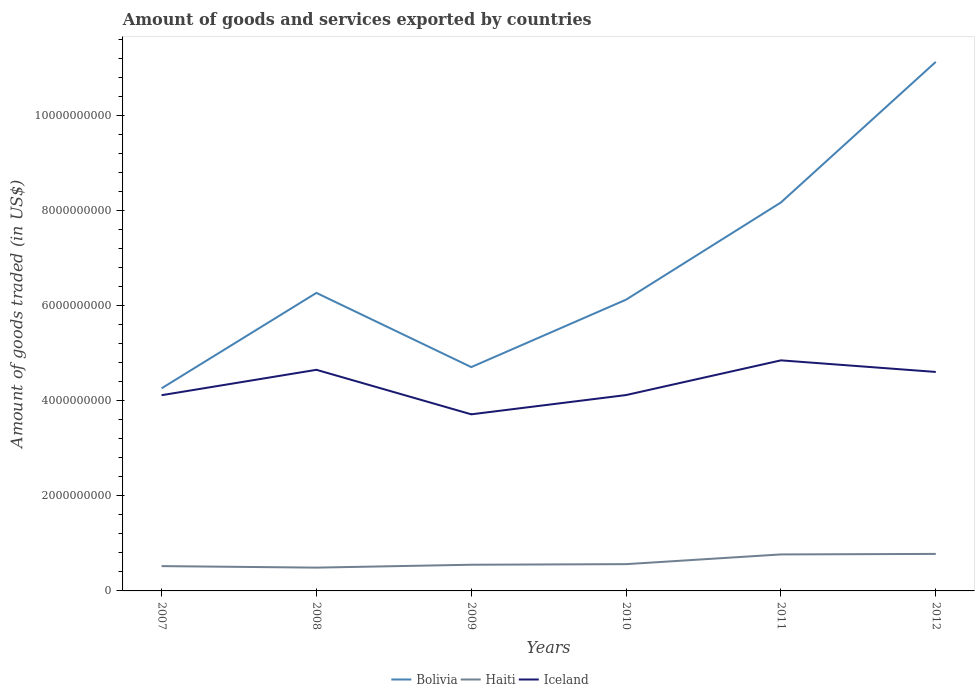Does the line corresponding to Bolivia intersect with the line corresponding to Haiti?
Keep it short and to the point. No. Is the number of lines equal to the number of legend labels?
Your answer should be very brief. Yes. Across all years, what is the maximum total amount of goods and services exported in Iceland?
Give a very brief answer. 3.72e+09. What is the total total amount of goods and services exported in Haiti in the graph?
Your answer should be compact. -2.89e+07. What is the difference between the highest and the second highest total amount of goods and services exported in Haiti?
Keep it short and to the point. 2.89e+08. What is the difference between the highest and the lowest total amount of goods and services exported in Iceland?
Ensure brevity in your answer.  3. Is the total amount of goods and services exported in Bolivia strictly greater than the total amount of goods and services exported in Haiti over the years?
Ensure brevity in your answer.  No. How many years are there in the graph?
Provide a succinct answer. 6. Does the graph contain grids?
Provide a succinct answer. No. Where does the legend appear in the graph?
Offer a very short reply. Bottom center. How are the legend labels stacked?
Your response must be concise. Horizontal. What is the title of the graph?
Provide a short and direct response. Amount of goods and services exported by countries. What is the label or title of the X-axis?
Ensure brevity in your answer.  Years. What is the label or title of the Y-axis?
Your response must be concise. Amount of goods traded (in US$). What is the Amount of goods traded (in US$) of Bolivia in 2007?
Give a very brief answer. 4.26e+09. What is the Amount of goods traded (in US$) in Haiti in 2007?
Offer a very short reply. 5.22e+08. What is the Amount of goods traded (in US$) of Iceland in 2007?
Your answer should be compact. 4.12e+09. What is the Amount of goods traded (in US$) in Bolivia in 2008?
Make the answer very short. 6.27e+09. What is the Amount of goods traded (in US$) of Haiti in 2008?
Offer a terse response. 4.90e+08. What is the Amount of goods traded (in US$) of Iceland in 2008?
Provide a short and direct response. 4.65e+09. What is the Amount of goods traded (in US$) of Bolivia in 2009?
Your response must be concise. 4.71e+09. What is the Amount of goods traded (in US$) of Haiti in 2009?
Offer a terse response. 5.51e+08. What is the Amount of goods traded (in US$) in Iceland in 2009?
Your response must be concise. 3.72e+09. What is the Amount of goods traded (in US$) in Bolivia in 2010?
Give a very brief answer. 6.13e+09. What is the Amount of goods traded (in US$) of Haiti in 2010?
Keep it short and to the point. 5.63e+08. What is the Amount of goods traded (in US$) of Iceland in 2010?
Keep it short and to the point. 4.12e+09. What is the Amount of goods traded (in US$) of Bolivia in 2011?
Provide a succinct answer. 8.17e+09. What is the Amount of goods traded (in US$) of Haiti in 2011?
Your answer should be very brief. 7.68e+08. What is the Amount of goods traded (in US$) of Iceland in 2011?
Give a very brief answer. 4.85e+09. What is the Amount of goods traded (in US$) in Bolivia in 2012?
Your response must be concise. 1.11e+1. What is the Amount of goods traded (in US$) in Haiti in 2012?
Provide a succinct answer. 7.79e+08. What is the Amount of goods traded (in US$) in Iceland in 2012?
Offer a very short reply. 4.61e+09. Across all years, what is the maximum Amount of goods traded (in US$) in Bolivia?
Provide a short and direct response. 1.11e+1. Across all years, what is the maximum Amount of goods traded (in US$) of Haiti?
Keep it short and to the point. 7.79e+08. Across all years, what is the maximum Amount of goods traded (in US$) of Iceland?
Your answer should be very brief. 4.85e+09. Across all years, what is the minimum Amount of goods traded (in US$) in Bolivia?
Make the answer very short. 4.26e+09. Across all years, what is the minimum Amount of goods traded (in US$) of Haiti?
Offer a very short reply. 4.90e+08. Across all years, what is the minimum Amount of goods traded (in US$) in Iceland?
Keep it short and to the point. 3.72e+09. What is the total Amount of goods traded (in US$) of Bolivia in the graph?
Your answer should be very brief. 4.07e+1. What is the total Amount of goods traded (in US$) of Haiti in the graph?
Make the answer very short. 3.67e+09. What is the total Amount of goods traded (in US$) in Iceland in the graph?
Give a very brief answer. 2.61e+1. What is the difference between the Amount of goods traded (in US$) of Bolivia in 2007 and that in 2008?
Keep it short and to the point. -2.01e+09. What is the difference between the Amount of goods traded (in US$) of Haiti in 2007 and that in 2008?
Make the answer very short. 3.19e+07. What is the difference between the Amount of goods traded (in US$) in Iceland in 2007 and that in 2008?
Provide a succinct answer. -5.34e+08. What is the difference between the Amount of goods traded (in US$) of Bolivia in 2007 and that in 2009?
Offer a terse response. -4.47e+08. What is the difference between the Amount of goods traded (in US$) of Haiti in 2007 and that in 2009?
Offer a very short reply. -2.89e+07. What is the difference between the Amount of goods traded (in US$) in Iceland in 2007 and that in 2009?
Give a very brief answer. 4.02e+08. What is the difference between the Amount of goods traded (in US$) in Bolivia in 2007 and that in 2010?
Provide a succinct answer. -1.87e+09. What is the difference between the Amount of goods traded (in US$) of Haiti in 2007 and that in 2010?
Ensure brevity in your answer.  -4.13e+07. What is the difference between the Amount of goods traded (in US$) of Iceland in 2007 and that in 2010?
Make the answer very short. -3.23e+06. What is the difference between the Amount of goods traded (in US$) in Bolivia in 2007 and that in 2011?
Give a very brief answer. -3.91e+09. What is the difference between the Amount of goods traded (in US$) of Haiti in 2007 and that in 2011?
Provide a short and direct response. -2.46e+08. What is the difference between the Amount of goods traded (in US$) in Iceland in 2007 and that in 2011?
Provide a succinct answer. -7.33e+08. What is the difference between the Amount of goods traded (in US$) in Bolivia in 2007 and that in 2012?
Offer a very short reply. -6.87e+09. What is the difference between the Amount of goods traded (in US$) of Haiti in 2007 and that in 2012?
Keep it short and to the point. -2.57e+08. What is the difference between the Amount of goods traded (in US$) of Iceland in 2007 and that in 2012?
Your response must be concise. -4.89e+08. What is the difference between the Amount of goods traded (in US$) in Bolivia in 2008 and that in 2009?
Ensure brevity in your answer.  1.56e+09. What is the difference between the Amount of goods traded (in US$) in Haiti in 2008 and that in 2009?
Give a very brief answer. -6.08e+07. What is the difference between the Amount of goods traded (in US$) in Iceland in 2008 and that in 2009?
Give a very brief answer. 9.37e+08. What is the difference between the Amount of goods traded (in US$) of Bolivia in 2008 and that in 2010?
Offer a terse response. 1.42e+08. What is the difference between the Amount of goods traded (in US$) of Haiti in 2008 and that in 2010?
Your answer should be compact. -7.32e+07. What is the difference between the Amount of goods traded (in US$) of Iceland in 2008 and that in 2010?
Your response must be concise. 5.31e+08. What is the difference between the Amount of goods traded (in US$) of Bolivia in 2008 and that in 2011?
Ensure brevity in your answer.  -1.90e+09. What is the difference between the Amount of goods traded (in US$) of Haiti in 2008 and that in 2011?
Your response must be concise. -2.78e+08. What is the difference between the Amount of goods traded (in US$) of Iceland in 2008 and that in 2011?
Offer a very short reply. -1.99e+08. What is the difference between the Amount of goods traded (in US$) of Bolivia in 2008 and that in 2012?
Your response must be concise. -4.86e+09. What is the difference between the Amount of goods traded (in US$) of Haiti in 2008 and that in 2012?
Provide a succinct answer. -2.89e+08. What is the difference between the Amount of goods traded (in US$) of Iceland in 2008 and that in 2012?
Make the answer very short. 4.49e+07. What is the difference between the Amount of goods traded (in US$) in Bolivia in 2009 and that in 2010?
Keep it short and to the point. -1.42e+09. What is the difference between the Amount of goods traded (in US$) of Haiti in 2009 and that in 2010?
Give a very brief answer. -1.24e+07. What is the difference between the Amount of goods traded (in US$) of Iceland in 2009 and that in 2010?
Your answer should be compact. -4.06e+08. What is the difference between the Amount of goods traded (in US$) of Bolivia in 2009 and that in 2011?
Offer a terse response. -3.47e+09. What is the difference between the Amount of goods traded (in US$) of Haiti in 2009 and that in 2011?
Offer a terse response. -2.17e+08. What is the difference between the Amount of goods traded (in US$) in Iceland in 2009 and that in 2011?
Your response must be concise. -1.14e+09. What is the difference between the Amount of goods traded (in US$) in Bolivia in 2009 and that in 2012?
Provide a succinct answer. -6.42e+09. What is the difference between the Amount of goods traded (in US$) of Haiti in 2009 and that in 2012?
Give a very brief answer. -2.28e+08. What is the difference between the Amount of goods traded (in US$) in Iceland in 2009 and that in 2012?
Your answer should be compact. -8.92e+08. What is the difference between the Amount of goods traded (in US$) in Bolivia in 2010 and that in 2011?
Provide a short and direct response. -2.05e+09. What is the difference between the Amount of goods traded (in US$) of Haiti in 2010 and that in 2011?
Provide a succinct answer. -2.05e+08. What is the difference between the Amount of goods traded (in US$) of Iceland in 2010 and that in 2011?
Your response must be concise. -7.30e+08. What is the difference between the Amount of goods traded (in US$) in Bolivia in 2010 and that in 2012?
Keep it short and to the point. -5.00e+09. What is the difference between the Amount of goods traded (in US$) of Haiti in 2010 and that in 2012?
Your answer should be very brief. -2.15e+08. What is the difference between the Amount of goods traded (in US$) in Iceland in 2010 and that in 2012?
Offer a terse response. -4.86e+08. What is the difference between the Amount of goods traded (in US$) in Bolivia in 2011 and that in 2012?
Your response must be concise. -2.96e+09. What is the difference between the Amount of goods traded (in US$) of Haiti in 2011 and that in 2012?
Your answer should be compact. -1.08e+07. What is the difference between the Amount of goods traded (in US$) of Iceland in 2011 and that in 2012?
Keep it short and to the point. 2.44e+08. What is the difference between the Amount of goods traded (in US$) of Bolivia in 2007 and the Amount of goods traded (in US$) of Haiti in 2008?
Your response must be concise. 3.77e+09. What is the difference between the Amount of goods traded (in US$) of Bolivia in 2007 and the Amount of goods traded (in US$) of Iceland in 2008?
Make the answer very short. -3.90e+08. What is the difference between the Amount of goods traded (in US$) of Haiti in 2007 and the Amount of goods traded (in US$) of Iceland in 2008?
Provide a succinct answer. -4.13e+09. What is the difference between the Amount of goods traded (in US$) in Bolivia in 2007 and the Amount of goods traded (in US$) in Haiti in 2009?
Your response must be concise. 3.71e+09. What is the difference between the Amount of goods traded (in US$) of Bolivia in 2007 and the Amount of goods traded (in US$) of Iceland in 2009?
Offer a terse response. 5.47e+08. What is the difference between the Amount of goods traded (in US$) in Haiti in 2007 and the Amount of goods traded (in US$) in Iceland in 2009?
Ensure brevity in your answer.  -3.19e+09. What is the difference between the Amount of goods traded (in US$) in Bolivia in 2007 and the Amount of goods traded (in US$) in Haiti in 2010?
Offer a very short reply. 3.70e+09. What is the difference between the Amount of goods traded (in US$) in Bolivia in 2007 and the Amount of goods traded (in US$) in Iceland in 2010?
Your answer should be very brief. 1.41e+08. What is the difference between the Amount of goods traded (in US$) in Haiti in 2007 and the Amount of goods traded (in US$) in Iceland in 2010?
Provide a short and direct response. -3.60e+09. What is the difference between the Amount of goods traded (in US$) of Bolivia in 2007 and the Amount of goods traded (in US$) of Haiti in 2011?
Keep it short and to the point. 3.49e+09. What is the difference between the Amount of goods traded (in US$) of Bolivia in 2007 and the Amount of goods traded (in US$) of Iceland in 2011?
Your answer should be compact. -5.89e+08. What is the difference between the Amount of goods traded (in US$) of Haiti in 2007 and the Amount of goods traded (in US$) of Iceland in 2011?
Ensure brevity in your answer.  -4.33e+09. What is the difference between the Amount of goods traded (in US$) of Bolivia in 2007 and the Amount of goods traded (in US$) of Haiti in 2012?
Your answer should be very brief. 3.48e+09. What is the difference between the Amount of goods traded (in US$) of Bolivia in 2007 and the Amount of goods traded (in US$) of Iceland in 2012?
Give a very brief answer. -3.45e+08. What is the difference between the Amount of goods traded (in US$) of Haiti in 2007 and the Amount of goods traded (in US$) of Iceland in 2012?
Make the answer very short. -4.09e+09. What is the difference between the Amount of goods traded (in US$) of Bolivia in 2008 and the Amount of goods traded (in US$) of Haiti in 2009?
Your answer should be very brief. 5.72e+09. What is the difference between the Amount of goods traded (in US$) in Bolivia in 2008 and the Amount of goods traded (in US$) in Iceland in 2009?
Provide a succinct answer. 2.56e+09. What is the difference between the Amount of goods traded (in US$) in Haiti in 2008 and the Amount of goods traded (in US$) in Iceland in 2009?
Offer a very short reply. -3.23e+09. What is the difference between the Amount of goods traded (in US$) in Bolivia in 2008 and the Amount of goods traded (in US$) in Haiti in 2010?
Offer a terse response. 5.71e+09. What is the difference between the Amount of goods traded (in US$) of Bolivia in 2008 and the Amount of goods traded (in US$) of Iceland in 2010?
Provide a short and direct response. 2.15e+09. What is the difference between the Amount of goods traded (in US$) of Haiti in 2008 and the Amount of goods traded (in US$) of Iceland in 2010?
Ensure brevity in your answer.  -3.63e+09. What is the difference between the Amount of goods traded (in US$) of Bolivia in 2008 and the Amount of goods traded (in US$) of Haiti in 2011?
Give a very brief answer. 5.50e+09. What is the difference between the Amount of goods traded (in US$) in Bolivia in 2008 and the Amount of goods traded (in US$) in Iceland in 2011?
Make the answer very short. 1.42e+09. What is the difference between the Amount of goods traded (in US$) of Haiti in 2008 and the Amount of goods traded (in US$) of Iceland in 2011?
Provide a succinct answer. -4.36e+09. What is the difference between the Amount of goods traded (in US$) of Bolivia in 2008 and the Amount of goods traded (in US$) of Haiti in 2012?
Keep it short and to the point. 5.49e+09. What is the difference between the Amount of goods traded (in US$) of Bolivia in 2008 and the Amount of goods traded (in US$) of Iceland in 2012?
Provide a succinct answer. 1.66e+09. What is the difference between the Amount of goods traded (in US$) in Haiti in 2008 and the Amount of goods traded (in US$) in Iceland in 2012?
Give a very brief answer. -4.12e+09. What is the difference between the Amount of goods traded (in US$) in Bolivia in 2009 and the Amount of goods traded (in US$) in Haiti in 2010?
Your answer should be compact. 4.15e+09. What is the difference between the Amount of goods traded (in US$) in Bolivia in 2009 and the Amount of goods traded (in US$) in Iceland in 2010?
Offer a very short reply. 5.88e+08. What is the difference between the Amount of goods traded (in US$) in Haiti in 2009 and the Amount of goods traded (in US$) in Iceland in 2010?
Ensure brevity in your answer.  -3.57e+09. What is the difference between the Amount of goods traded (in US$) in Bolivia in 2009 and the Amount of goods traded (in US$) in Haiti in 2011?
Make the answer very short. 3.94e+09. What is the difference between the Amount of goods traded (in US$) in Bolivia in 2009 and the Amount of goods traded (in US$) in Iceland in 2011?
Keep it short and to the point. -1.42e+08. What is the difference between the Amount of goods traded (in US$) in Haiti in 2009 and the Amount of goods traded (in US$) in Iceland in 2011?
Offer a terse response. -4.30e+09. What is the difference between the Amount of goods traded (in US$) of Bolivia in 2009 and the Amount of goods traded (in US$) of Haiti in 2012?
Offer a terse response. 3.93e+09. What is the difference between the Amount of goods traded (in US$) of Bolivia in 2009 and the Amount of goods traded (in US$) of Iceland in 2012?
Your answer should be very brief. 1.02e+08. What is the difference between the Amount of goods traded (in US$) in Haiti in 2009 and the Amount of goods traded (in US$) in Iceland in 2012?
Your response must be concise. -4.06e+09. What is the difference between the Amount of goods traded (in US$) in Bolivia in 2010 and the Amount of goods traded (in US$) in Haiti in 2011?
Offer a terse response. 5.36e+09. What is the difference between the Amount of goods traded (in US$) of Bolivia in 2010 and the Amount of goods traded (in US$) of Iceland in 2011?
Make the answer very short. 1.28e+09. What is the difference between the Amount of goods traded (in US$) in Haiti in 2010 and the Amount of goods traded (in US$) in Iceland in 2011?
Keep it short and to the point. -4.29e+09. What is the difference between the Amount of goods traded (in US$) in Bolivia in 2010 and the Amount of goods traded (in US$) in Haiti in 2012?
Your answer should be very brief. 5.35e+09. What is the difference between the Amount of goods traded (in US$) of Bolivia in 2010 and the Amount of goods traded (in US$) of Iceland in 2012?
Your answer should be compact. 1.52e+09. What is the difference between the Amount of goods traded (in US$) in Haiti in 2010 and the Amount of goods traded (in US$) in Iceland in 2012?
Your response must be concise. -4.04e+09. What is the difference between the Amount of goods traded (in US$) of Bolivia in 2011 and the Amount of goods traded (in US$) of Haiti in 2012?
Ensure brevity in your answer.  7.40e+09. What is the difference between the Amount of goods traded (in US$) in Bolivia in 2011 and the Amount of goods traded (in US$) in Iceland in 2012?
Your answer should be very brief. 3.57e+09. What is the difference between the Amount of goods traded (in US$) in Haiti in 2011 and the Amount of goods traded (in US$) in Iceland in 2012?
Your answer should be very brief. -3.84e+09. What is the average Amount of goods traded (in US$) of Bolivia per year?
Make the answer very short. 6.78e+09. What is the average Amount of goods traded (in US$) in Haiti per year?
Make the answer very short. 6.12e+08. What is the average Amount of goods traded (in US$) of Iceland per year?
Offer a very short reply. 4.34e+09. In the year 2007, what is the difference between the Amount of goods traded (in US$) of Bolivia and Amount of goods traded (in US$) of Haiti?
Provide a short and direct response. 3.74e+09. In the year 2007, what is the difference between the Amount of goods traded (in US$) of Bolivia and Amount of goods traded (in US$) of Iceland?
Offer a terse response. 1.44e+08. In the year 2007, what is the difference between the Amount of goods traded (in US$) of Haiti and Amount of goods traded (in US$) of Iceland?
Your answer should be very brief. -3.60e+09. In the year 2008, what is the difference between the Amount of goods traded (in US$) in Bolivia and Amount of goods traded (in US$) in Haiti?
Ensure brevity in your answer.  5.78e+09. In the year 2008, what is the difference between the Amount of goods traded (in US$) of Bolivia and Amount of goods traded (in US$) of Iceland?
Make the answer very short. 1.62e+09. In the year 2008, what is the difference between the Amount of goods traded (in US$) of Haiti and Amount of goods traded (in US$) of Iceland?
Your answer should be compact. -4.16e+09. In the year 2009, what is the difference between the Amount of goods traded (in US$) in Bolivia and Amount of goods traded (in US$) in Haiti?
Make the answer very short. 4.16e+09. In the year 2009, what is the difference between the Amount of goods traded (in US$) in Bolivia and Amount of goods traded (in US$) in Iceland?
Your answer should be very brief. 9.94e+08. In the year 2009, what is the difference between the Amount of goods traded (in US$) of Haiti and Amount of goods traded (in US$) of Iceland?
Make the answer very short. -3.17e+09. In the year 2010, what is the difference between the Amount of goods traded (in US$) of Bolivia and Amount of goods traded (in US$) of Haiti?
Offer a very short reply. 5.57e+09. In the year 2010, what is the difference between the Amount of goods traded (in US$) in Bolivia and Amount of goods traded (in US$) in Iceland?
Ensure brevity in your answer.  2.01e+09. In the year 2010, what is the difference between the Amount of goods traded (in US$) in Haiti and Amount of goods traded (in US$) in Iceland?
Make the answer very short. -3.56e+09. In the year 2011, what is the difference between the Amount of goods traded (in US$) of Bolivia and Amount of goods traded (in US$) of Haiti?
Make the answer very short. 7.41e+09. In the year 2011, what is the difference between the Amount of goods traded (in US$) of Bolivia and Amount of goods traded (in US$) of Iceland?
Provide a short and direct response. 3.32e+09. In the year 2011, what is the difference between the Amount of goods traded (in US$) of Haiti and Amount of goods traded (in US$) of Iceland?
Your response must be concise. -4.08e+09. In the year 2012, what is the difference between the Amount of goods traded (in US$) of Bolivia and Amount of goods traded (in US$) of Haiti?
Provide a short and direct response. 1.04e+1. In the year 2012, what is the difference between the Amount of goods traded (in US$) in Bolivia and Amount of goods traded (in US$) in Iceland?
Provide a short and direct response. 6.52e+09. In the year 2012, what is the difference between the Amount of goods traded (in US$) in Haiti and Amount of goods traded (in US$) in Iceland?
Your answer should be very brief. -3.83e+09. What is the ratio of the Amount of goods traded (in US$) in Bolivia in 2007 to that in 2008?
Provide a short and direct response. 0.68. What is the ratio of the Amount of goods traded (in US$) of Haiti in 2007 to that in 2008?
Provide a succinct answer. 1.06. What is the ratio of the Amount of goods traded (in US$) in Iceland in 2007 to that in 2008?
Give a very brief answer. 0.89. What is the ratio of the Amount of goods traded (in US$) in Bolivia in 2007 to that in 2009?
Your answer should be very brief. 0.91. What is the ratio of the Amount of goods traded (in US$) of Haiti in 2007 to that in 2009?
Offer a terse response. 0.95. What is the ratio of the Amount of goods traded (in US$) of Iceland in 2007 to that in 2009?
Your answer should be compact. 1.11. What is the ratio of the Amount of goods traded (in US$) in Bolivia in 2007 to that in 2010?
Your answer should be very brief. 0.7. What is the ratio of the Amount of goods traded (in US$) of Haiti in 2007 to that in 2010?
Make the answer very short. 0.93. What is the ratio of the Amount of goods traded (in US$) in Bolivia in 2007 to that in 2011?
Give a very brief answer. 0.52. What is the ratio of the Amount of goods traded (in US$) of Haiti in 2007 to that in 2011?
Offer a terse response. 0.68. What is the ratio of the Amount of goods traded (in US$) of Iceland in 2007 to that in 2011?
Your answer should be very brief. 0.85. What is the ratio of the Amount of goods traded (in US$) in Bolivia in 2007 to that in 2012?
Make the answer very short. 0.38. What is the ratio of the Amount of goods traded (in US$) of Haiti in 2007 to that in 2012?
Make the answer very short. 0.67. What is the ratio of the Amount of goods traded (in US$) in Iceland in 2007 to that in 2012?
Offer a terse response. 0.89. What is the ratio of the Amount of goods traded (in US$) of Bolivia in 2008 to that in 2009?
Give a very brief answer. 1.33. What is the ratio of the Amount of goods traded (in US$) of Haiti in 2008 to that in 2009?
Provide a short and direct response. 0.89. What is the ratio of the Amount of goods traded (in US$) in Iceland in 2008 to that in 2009?
Your answer should be very brief. 1.25. What is the ratio of the Amount of goods traded (in US$) of Bolivia in 2008 to that in 2010?
Make the answer very short. 1.02. What is the ratio of the Amount of goods traded (in US$) in Haiti in 2008 to that in 2010?
Offer a terse response. 0.87. What is the ratio of the Amount of goods traded (in US$) in Iceland in 2008 to that in 2010?
Offer a terse response. 1.13. What is the ratio of the Amount of goods traded (in US$) of Bolivia in 2008 to that in 2011?
Give a very brief answer. 0.77. What is the ratio of the Amount of goods traded (in US$) of Haiti in 2008 to that in 2011?
Offer a very short reply. 0.64. What is the ratio of the Amount of goods traded (in US$) in Bolivia in 2008 to that in 2012?
Ensure brevity in your answer.  0.56. What is the ratio of the Amount of goods traded (in US$) of Haiti in 2008 to that in 2012?
Keep it short and to the point. 0.63. What is the ratio of the Amount of goods traded (in US$) of Iceland in 2008 to that in 2012?
Provide a short and direct response. 1.01. What is the ratio of the Amount of goods traded (in US$) of Bolivia in 2009 to that in 2010?
Provide a short and direct response. 0.77. What is the ratio of the Amount of goods traded (in US$) of Haiti in 2009 to that in 2010?
Offer a very short reply. 0.98. What is the ratio of the Amount of goods traded (in US$) in Iceland in 2009 to that in 2010?
Your answer should be compact. 0.9. What is the ratio of the Amount of goods traded (in US$) of Bolivia in 2009 to that in 2011?
Keep it short and to the point. 0.58. What is the ratio of the Amount of goods traded (in US$) in Haiti in 2009 to that in 2011?
Provide a succinct answer. 0.72. What is the ratio of the Amount of goods traded (in US$) of Iceland in 2009 to that in 2011?
Your answer should be compact. 0.77. What is the ratio of the Amount of goods traded (in US$) in Bolivia in 2009 to that in 2012?
Offer a terse response. 0.42. What is the ratio of the Amount of goods traded (in US$) of Haiti in 2009 to that in 2012?
Offer a terse response. 0.71. What is the ratio of the Amount of goods traded (in US$) of Iceland in 2009 to that in 2012?
Your answer should be very brief. 0.81. What is the ratio of the Amount of goods traded (in US$) in Bolivia in 2010 to that in 2011?
Your answer should be compact. 0.75. What is the ratio of the Amount of goods traded (in US$) of Haiti in 2010 to that in 2011?
Your answer should be very brief. 0.73. What is the ratio of the Amount of goods traded (in US$) in Iceland in 2010 to that in 2011?
Make the answer very short. 0.85. What is the ratio of the Amount of goods traded (in US$) in Bolivia in 2010 to that in 2012?
Your answer should be very brief. 0.55. What is the ratio of the Amount of goods traded (in US$) in Haiti in 2010 to that in 2012?
Provide a succinct answer. 0.72. What is the ratio of the Amount of goods traded (in US$) in Iceland in 2010 to that in 2012?
Give a very brief answer. 0.89. What is the ratio of the Amount of goods traded (in US$) of Bolivia in 2011 to that in 2012?
Your answer should be very brief. 0.73. What is the ratio of the Amount of goods traded (in US$) of Haiti in 2011 to that in 2012?
Make the answer very short. 0.99. What is the ratio of the Amount of goods traded (in US$) of Iceland in 2011 to that in 2012?
Keep it short and to the point. 1.05. What is the difference between the highest and the second highest Amount of goods traded (in US$) of Bolivia?
Provide a succinct answer. 2.96e+09. What is the difference between the highest and the second highest Amount of goods traded (in US$) of Haiti?
Offer a terse response. 1.08e+07. What is the difference between the highest and the second highest Amount of goods traded (in US$) in Iceland?
Make the answer very short. 1.99e+08. What is the difference between the highest and the lowest Amount of goods traded (in US$) in Bolivia?
Keep it short and to the point. 6.87e+09. What is the difference between the highest and the lowest Amount of goods traded (in US$) in Haiti?
Make the answer very short. 2.89e+08. What is the difference between the highest and the lowest Amount of goods traded (in US$) in Iceland?
Make the answer very short. 1.14e+09. 